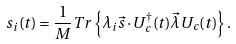<formula> <loc_0><loc_0><loc_500><loc_500>s _ { i } ( t ) = \frac { 1 } { M } T r \left \{ \lambda _ { i } \vec { s } \cdot U ^ { \dagger } _ { c } ( t ) \vec { \lambda } U _ { c } ( t ) \right \} .</formula> 